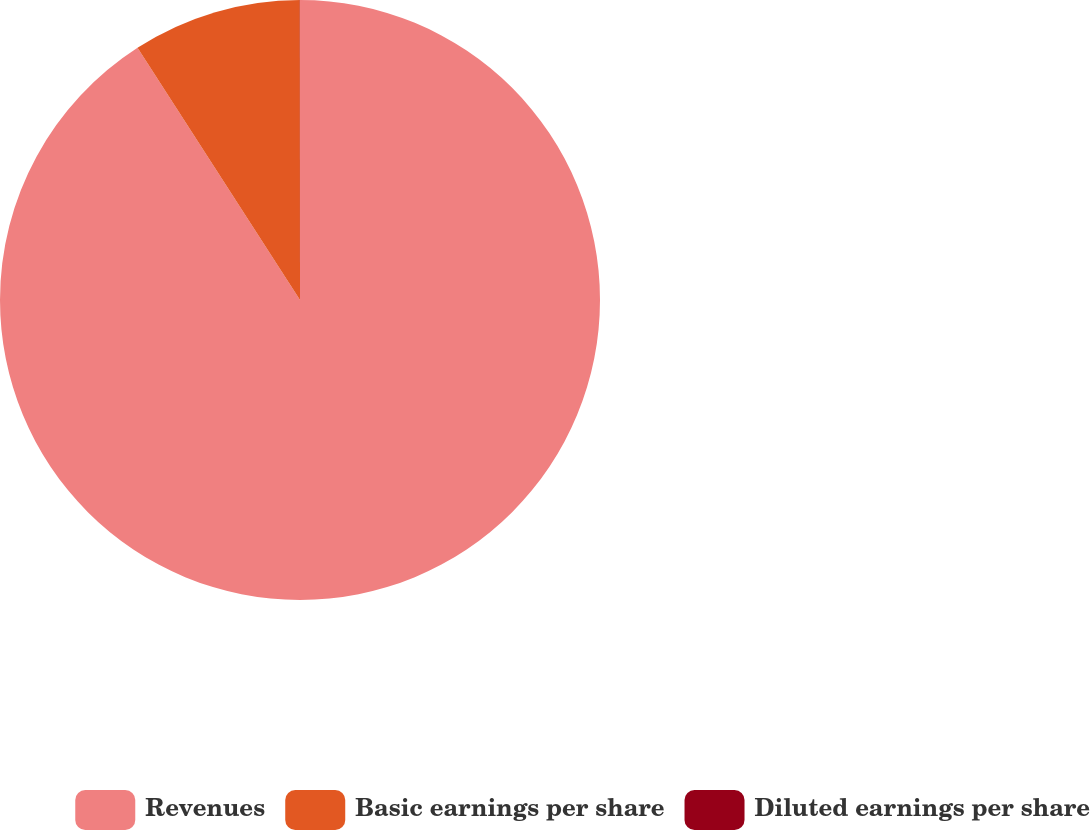Convert chart to OTSL. <chart><loc_0><loc_0><loc_500><loc_500><pie_chart><fcel>Revenues<fcel>Basic earnings per share<fcel>Diluted earnings per share<nl><fcel>90.89%<fcel>9.1%<fcel>0.01%<nl></chart> 